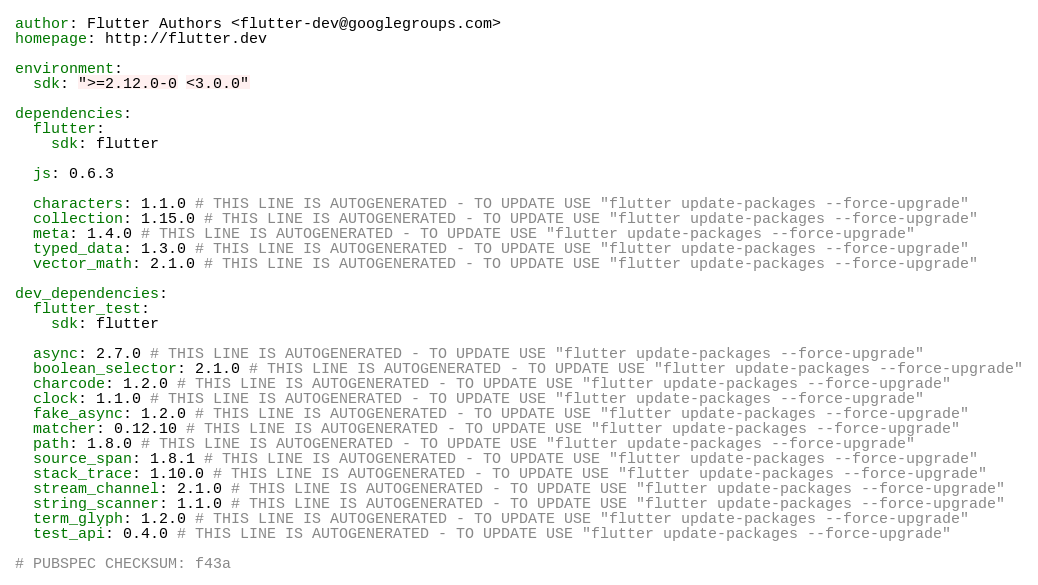Convert code to text. <code><loc_0><loc_0><loc_500><loc_500><_YAML_>author: Flutter Authors <flutter-dev@googlegroups.com>
homepage: http://flutter.dev

environment:
  sdk: ">=2.12.0-0 <3.0.0"

dependencies:
  flutter:
    sdk: flutter

  js: 0.6.3

  characters: 1.1.0 # THIS LINE IS AUTOGENERATED - TO UPDATE USE "flutter update-packages --force-upgrade"
  collection: 1.15.0 # THIS LINE IS AUTOGENERATED - TO UPDATE USE "flutter update-packages --force-upgrade"
  meta: 1.4.0 # THIS LINE IS AUTOGENERATED - TO UPDATE USE "flutter update-packages --force-upgrade"
  typed_data: 1.3.0 # THIS LINE IS AUTOGENERATED - TO UPDATE USE "flutter update-packages --force-upgrade"
  vector_math: 2.1.0 # THIS LINE IS AUTOGENERATED - TO UPDATE USE "flutter update-packages --force-upgrade"

dev_dependencies:
  flutter_test:
    sdk: flutter

  async: 2.7.0 # THIS LINE IS AUTOGENERATED - TO UPDATE USE "flutter update-packages --force-upgrade"
  boolean_selector: 2.1.0 # THIS LINE IS AUTOGENERATED - TO UPDATE USE "flutter update-packages --force-upgrade"
  charcode: 1.2.0 # THIS LINE IS AUTOGENERATED - TO UPDATE USE "flutter update-packages --force-upgrade"
  clock: 1.1.0 # THIS LINE IS AUTOGENERATED - TO UPDATE USE "flutter update-packages --force-upgrade"
  fake_async: 1.2.0 # THIS LINE IS AUTOGENERATED - TO UPDATE USE "flutter update-packages --force-upgrade"
  matcher: 0.12.10 # THIS LINE IS AUTOGENERATED - TO UPDATE USE "flutter update-packages --force-upgrade"
  path: 1.8.0 # THIS LINE IS AUTOGENERATED - TO UPDATE USE "flutter update-packages --force-upgrade"
  source_span: 1.8.1 # THIS LINE IS AUTOGENERATED - TO UPDATE USE "flutter update-packages --force-upgrade"
  stack_trace: 1.10.0 # THIS LINE IS AUTOGENERATED - TO UPDATE USE "flutter update-packages --force-upgrade"
  stream_channel: 2.1.0 # THIS LINE IS AUTOGENERATED - TO UPDATE USE "flutter update-packages --force-upgrade"
  string_scanner: 1.1.0 # THIS LINE IS AUTOGENERATED - TO UPDATE USE "flutter update-packages --force-upgrade"
  term_glyph: 1.2.0 # THIS LINE IS AUTOGENERATED - TO UPDATE USE "flutter update-packages --force-upgrade"
  test_api: 0.4.0 # THIS LINE IS AUTOGENERATED - TO UPDATE USE "flutter update-packages --force-upgrade"

# PUBSPEC CHECKSUM: f43a
</code> 